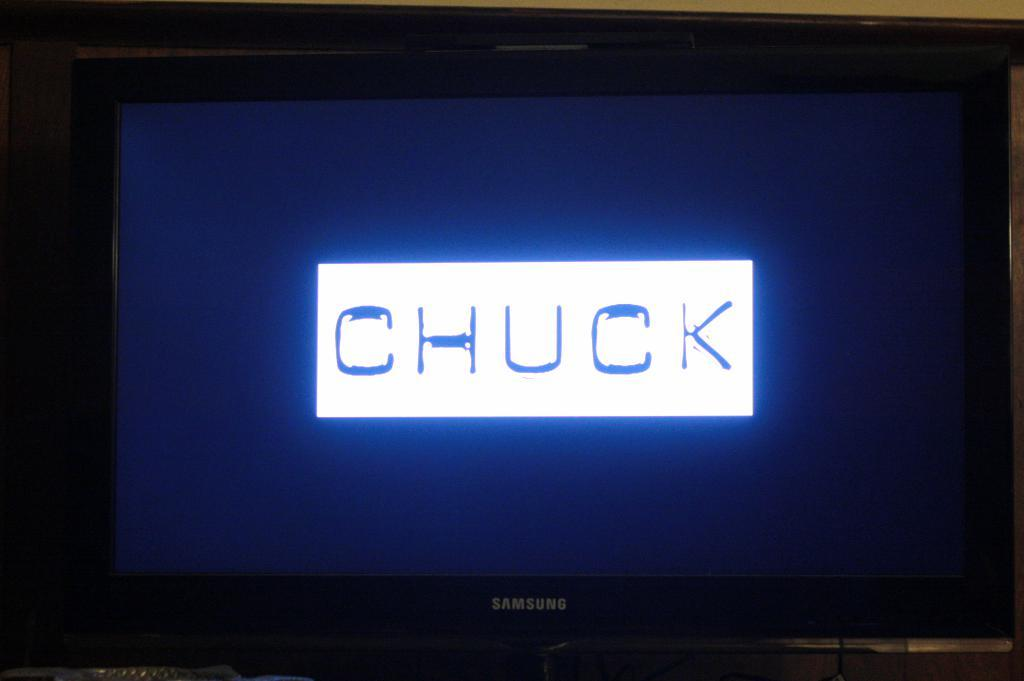<image>
Share a concise interpretation of the image provided. A Samsung TV is about to play a tv show called CHUCK. 